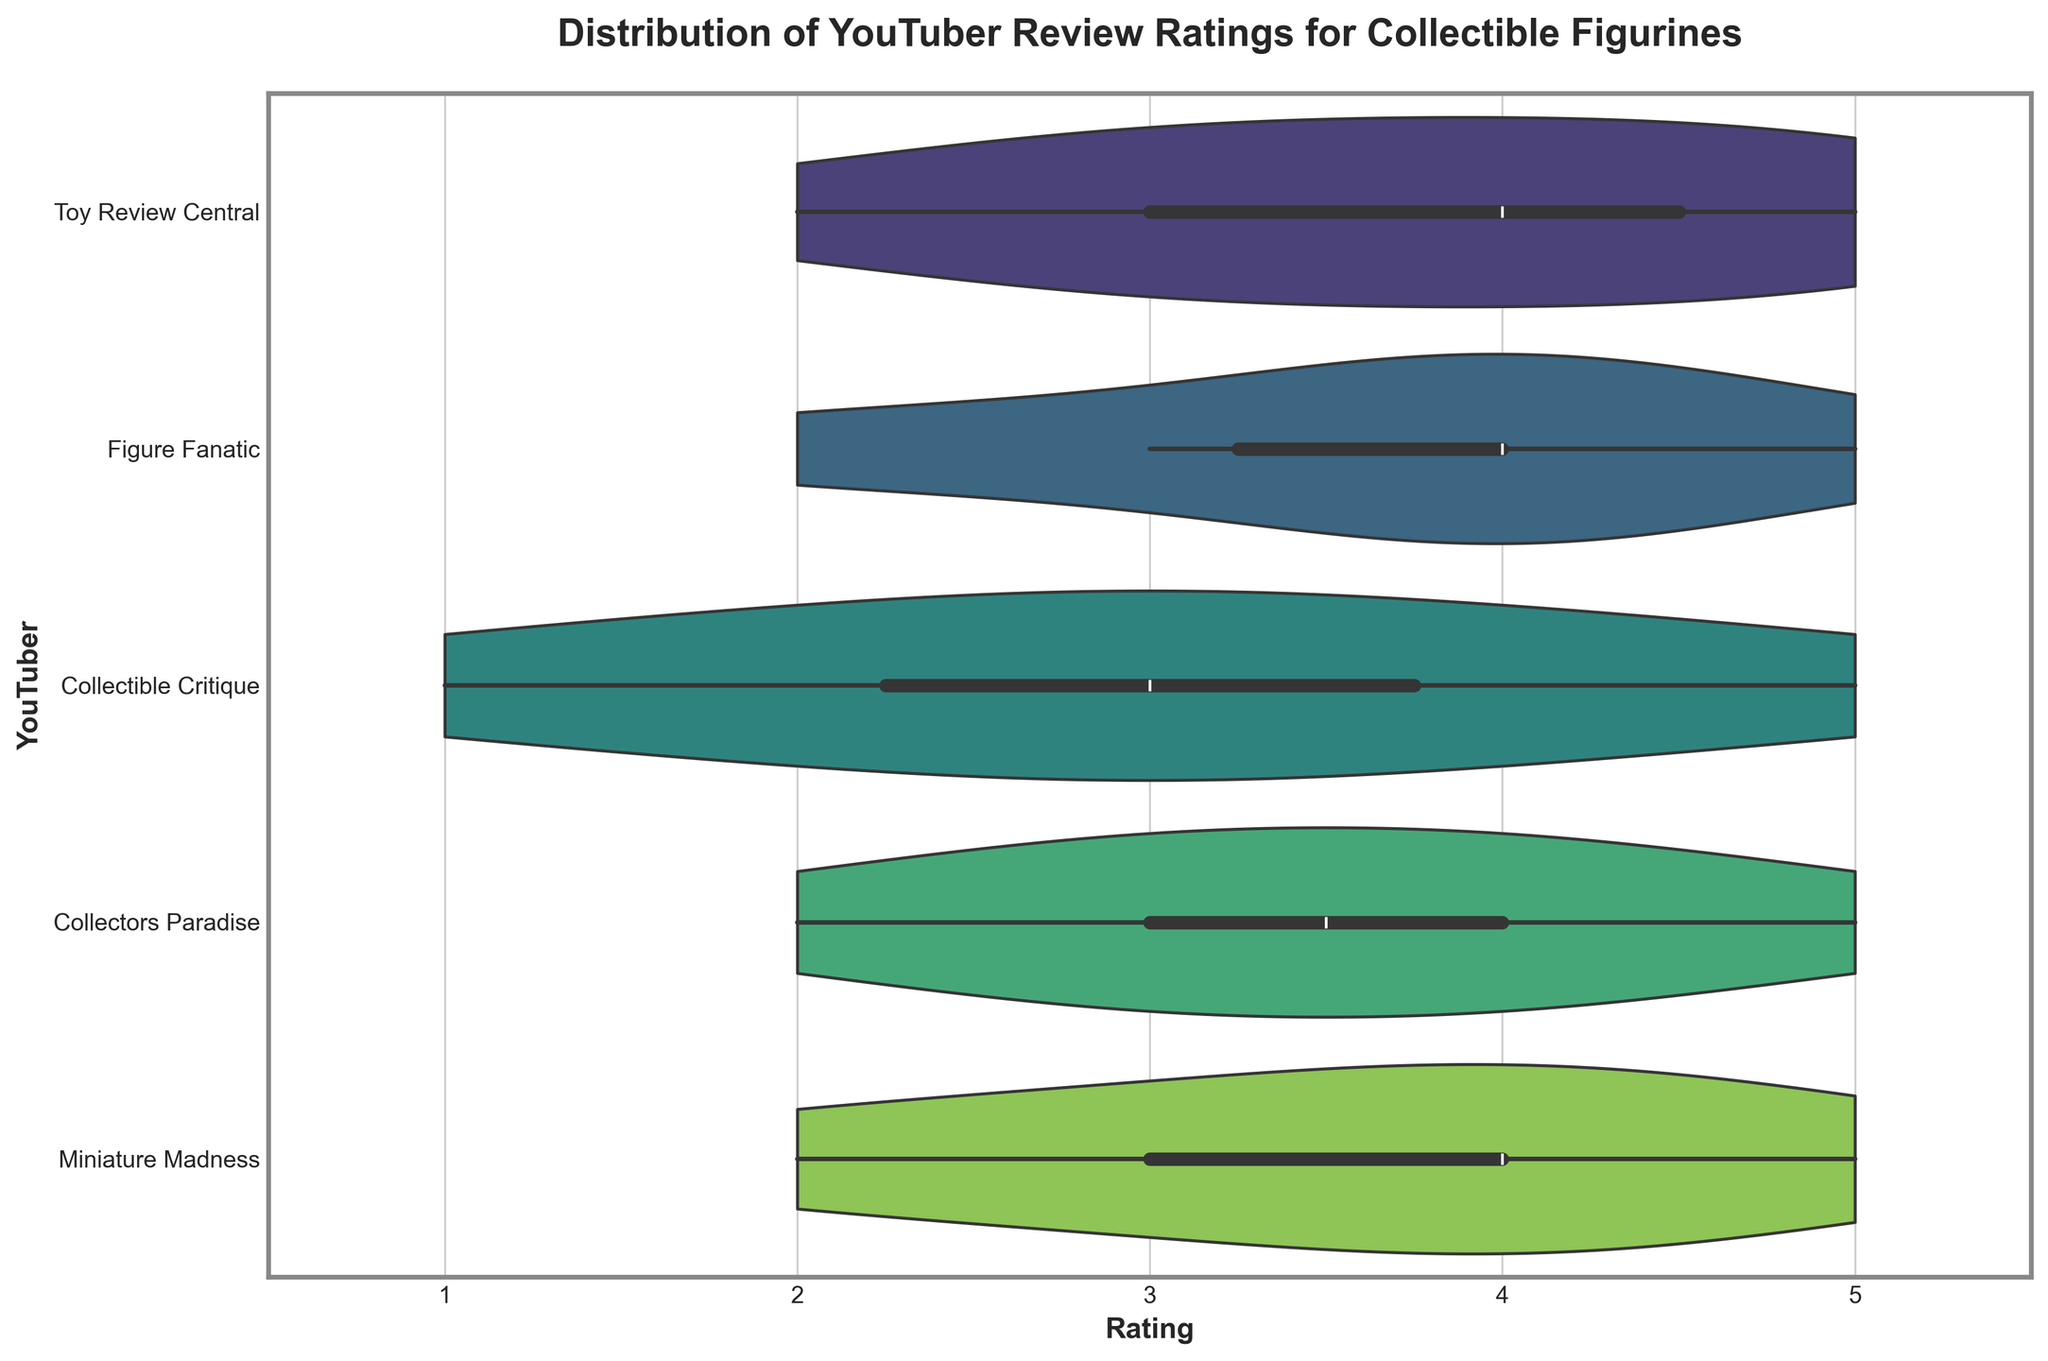What is the title of the plot? The title of the plot is located at the top of the figure and gives a summary of what the chart is about: 'Distribution of YouTuber Review Ratings for Collectible Figurines'.
Answer: 'Distribution of YouTuber Review Ratings for Collectible Figurines' Which YouTuber has the widest distribution of review ratings? By examining the spread of the distributions along the X-axis, you can see that 'Toy Review Central' has a wide range of ratings extending from 2 to 5. This indicates that it has the widest distribution of review ratings.
Answer: 'Toy Review Central' What is the median rating for 'Figure Fanatic'? In a violin plot with an inner box, the median value is typically indicated by a white dot within the box. For 'Figure Fanatic', this white dot is located at the 4 rating.
Answer: 4 How many YouTubers have their highest density of ratings at 4 stars? To determine this, you observe the peaks in the violin plots, which represent the highest densities. 'Figure Fanatic', 'Collectors Paradise', and 'Miniature Madness' have their highest density at 4 stars.
Answer: Three Which YouTuber has the least variability in their ratings? Variability can be assessed by looking at the width of the distribution. 'Collectible Critique' has a relatively narrow distribution centered around 3 stars, suggesting the least variability.
Answer: 'Collectible Critique' What is the interquartile range (IQR) of ratings for 'Miniature Madness'? The IQR is represented by the length of the box within the violin plot, located between the 25th and 75th percentiles. For 'Miniature Madness', the box spans from 3 to 4 stars, giving it an IQR of 1 (4-3).
Answer: 1 Which YouTuber has the highest median rating? By observing the median ratings (white dots) in the violin boxes, 'Collectors Paradise' and 'Miniature Madness' both have a median rating of 4.
Answer: 'Collectors Paradise' and 'Miniature Madness' Are there any YouTubers who have given a rating of 1 star? Examining the extent of the distributions, you see that 'Collectible Critique' includes a rating of 1 star.
Answer: 'Collectible Critique' 